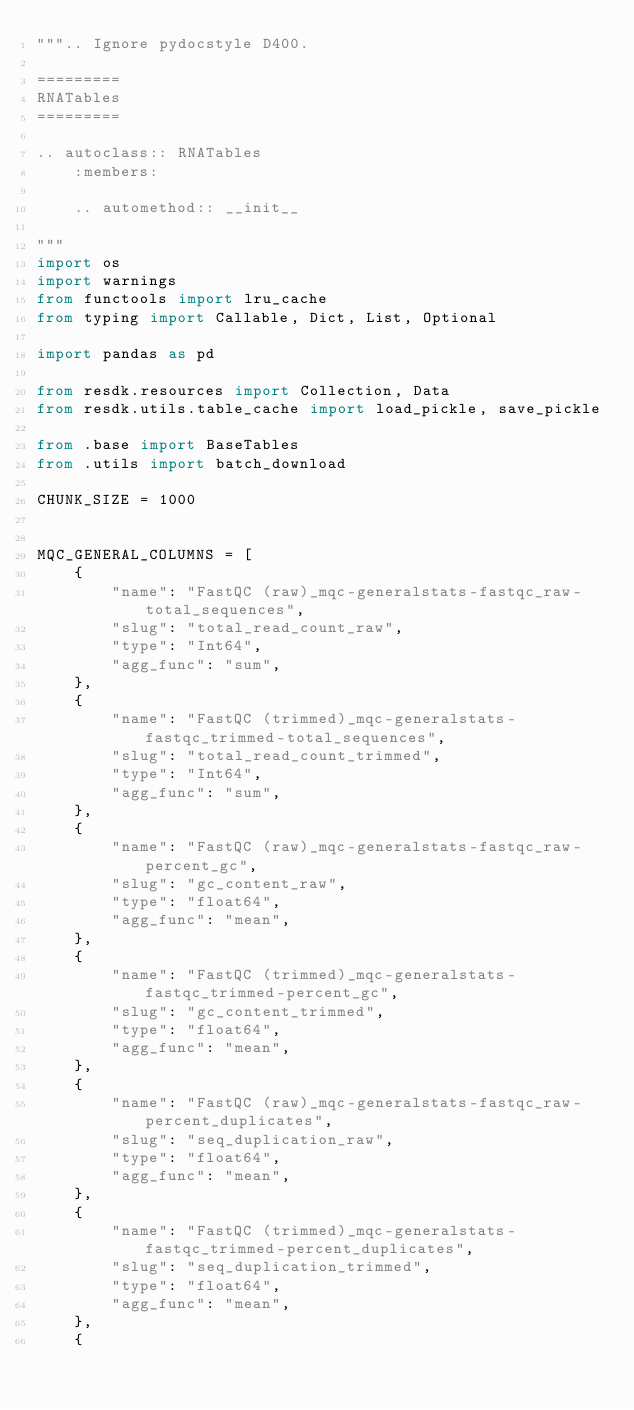<code> <loc_0><loc_0><loc_500><loc_500><_Python_>""".. Ignore pydocstyle D400.

=========
RNATables
=========

.. autoclass:: RNATables
    :members:

    .. automethod:: __init__

"""
import os
import warnings
from functools import lru_cache
from typing import Callable, Dict, List, Optional

import pandas as pd

from resdk.resources import Collection, Data
from resdk.utils.table_cache import load_pickle, save_pickle

from .base import BaseTables
from .utils import batch_download

CHUNK_SIZE = 1000


MQC_GENERAL_COLUMNS = [
    {
        "name": "FastQC (raw)_mqc-generalstats-fastqc_raw-total_sequences",
        "slug": "total_read_count_raw",
        "type": "Int64",
        "agg_func": "sum",
    },
    {
        "name": "FastQC (trimmed)_mqc-generalstats-fastqc_trimmed-total_sequences",
        "slug": "total_read_count_trimmed",
        "type": "Int64",
        "agg_func": "sum",
    },
    {
        "name": "FastQC (raw)_mqc-generalstats-fastqc_raw-percent_gc",
        "slug": "gc_content_raw",
        "type": "float64",
        "agg_func": "mean",
    },
    {
        "name": "FastQC (trimmed)_mqc-generalstats-fastqc_trimmed-percent_gc",
        "slug": "gc_content_trimmed",
        "type": "float64",
        "agg_func": "mean",
    },
    {
        "name": "FastQC (raw)_mqc-generalstats-fastqc_raw-percent_duplicates",
        "slug": "seq_duplication_raw",
        "type": "float64",
        "agg_func": "mean",
    },
    {
        "name": "FastQC (trimmed)_mqc-generalstats-fastqc_trimmed-percent_duplicates",
        "slug": "seq_duplication_trimmed",
        "type": "float64",
        "agg_func": "mean",
    },
    {</code> 